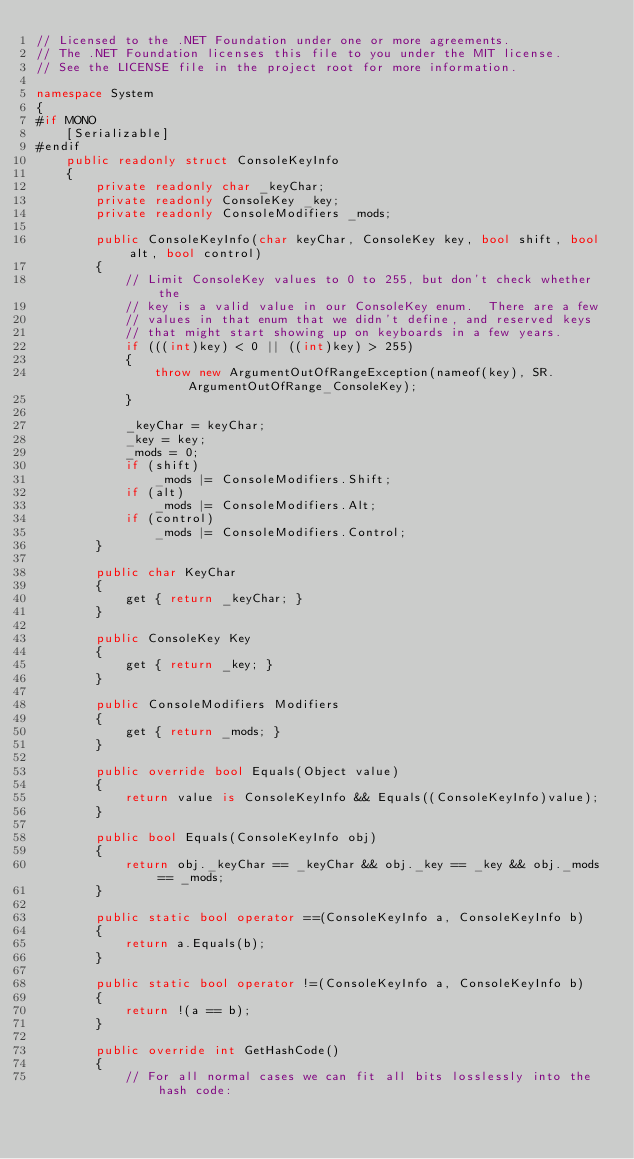<code> <loc_0><loc_0><loc_500><loc_500><_C#_>// Licensed to the .NET Foundation under one or more agreements.
// The .NET Foundation licenses this file to you under the MIT license.
// See the LICENSE file in the project root for more information.

namespace System
{
#if MONO
    [Serializable]
#endif
    public readonly struct ConsoleKeyInfo
    {
        private readonly char _keyChar;
        private readonly ConsoleKey _key;
        private readonly ConsoleModifiers _mods;

        public ConsoleKeyInfo(char keyChar, ConsoleKey key, bool shift, bool alt, bool control)
        {
            // Limit ConsoleKey values to 0 to 255, but don't check whether the
            // key is a valid value in our ConsoleKey enum.  There are a few 
            // values in that enum that we didn't define, and reserved keys 
            // that might start showing up on keyboards in a few years.
            if (((int)key) < 0 || ((int)key) > 255)
            {
                throw new ArgumentOutOfRangeException(nameof(key), SR.ArgumentOutOfRange_ConsoleKey);
            }

            _keyChar = keyChar;
            _key = key;
            _mods = 0;
            if (shift)
                _mods |= ConsoleModifiers.Shift;
            if (alt)
                _mods |= ConsoleModifiers.Alt;
            if (control)
                _mods |= ConsoleModifiers.Control;
        }

        public char KeyChar
        {
            get { return _keyChar; }
        }

        public ConsoleKey Key
        {
            get { return _key; }
        }

        public ConsoleModifiers Modifiers
        {
            get { return _mods; }
        }

        public override bool Equals(Object value)
        {
            return value is ConsoleKeyInfo && Equals((ConsoleKeyInfo)value);
        }

        public bool Equals(ConsoleKeyInfo obj)
        {
            return obj._keyChar == _keyChar && obj._key == _key && obj._mods == _mods;
        }

        public static bool operator ==(ConsoleKeyInfo a, ConsoleKeyInfo b)
        {
            return a.Equals(b);
        }

        public static bool operator !=(ConsoleKeyInfo a, ConsoleKeyInfo b)
        {
            return !(a == b);
        }

        public override int GetHashCode()
        {
            // For all normal cases we can fit all bits losslessly into the hash code:</code> 